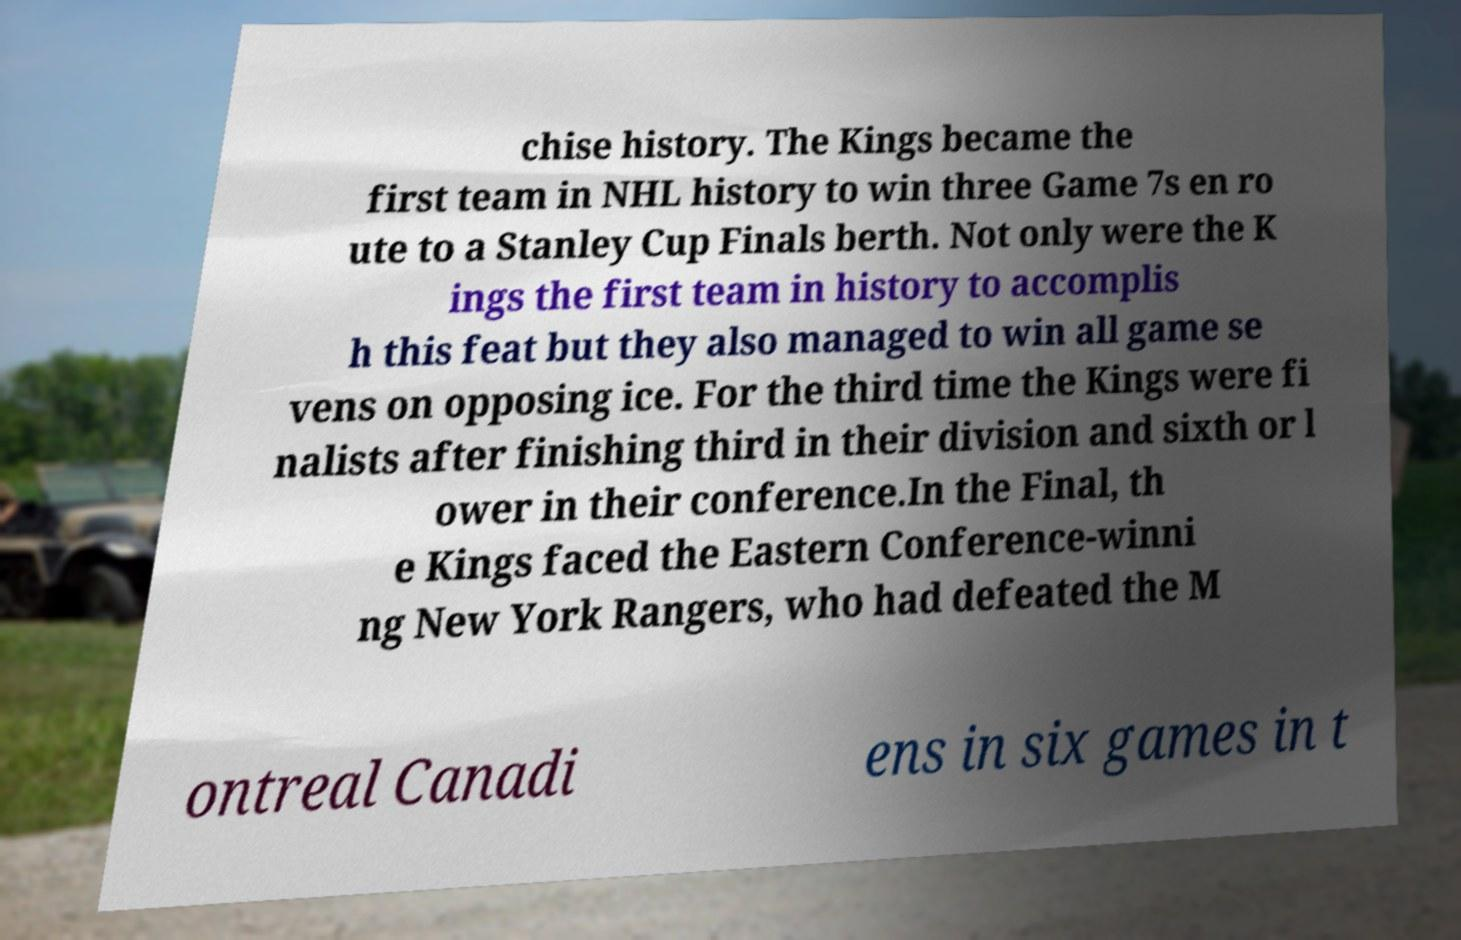Could you extract and type out the text from this image? chise history. The Kings became the first team in NHL history to win three Game 7s en ro ute to a Stanley Cup Finals berth. Not only were the K ings the first team in history to accomplis h this feat but they also managed to win all game se vens on opposing ice. For the third time the Kings were fi nalists after finishing third in their division and sixth or l ower in their conference.In the Final, th e Kings faced the Eastern Conference-winni ng New York Rangers, who had defeated the M ontreal Canadi ens in six games in t 